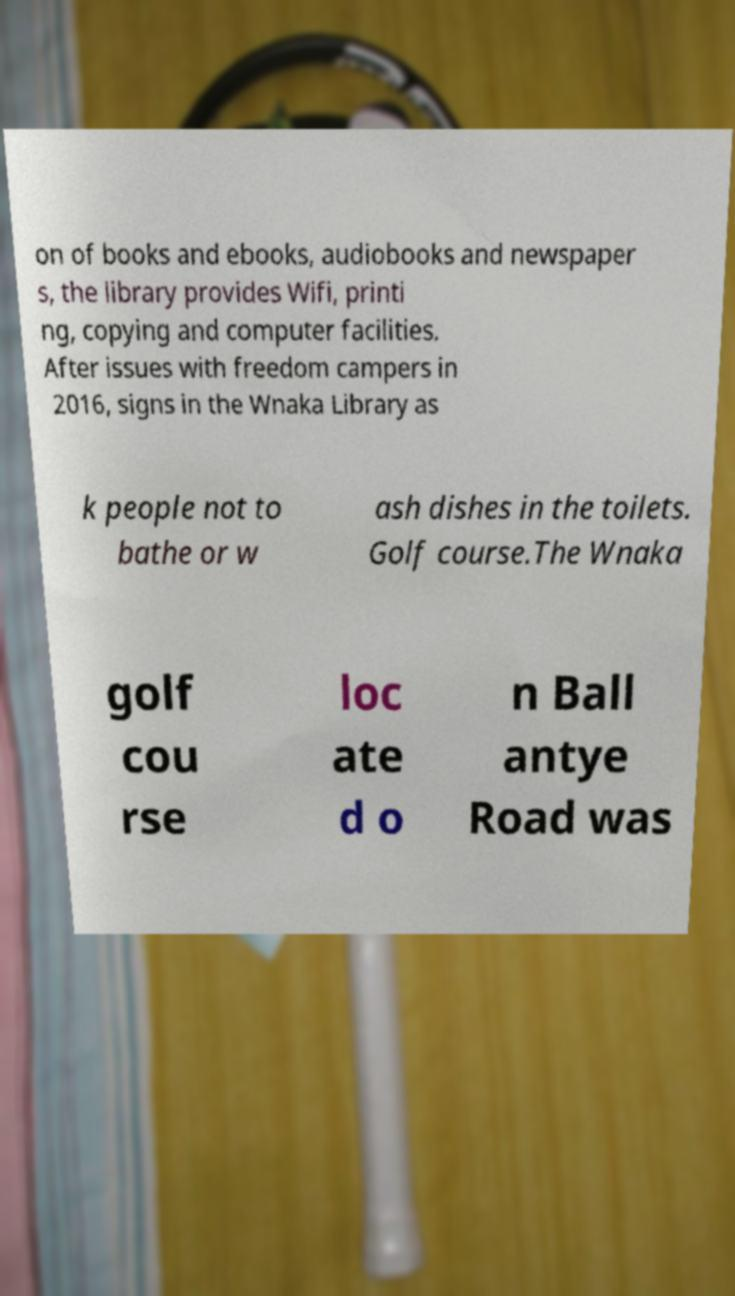Please identify and transcribe the text found in this image. on of books and ebooks, audiobooks and newspaper s, the library provides Wifi, printi ng, copying and computer facilities. After issues with freedom campers in 2016, signs in the Wnaka Library as k people not to bathe or w ash dishes in the toilets. Golf course.The Wnaka golf cou rse loc ate d o n Ball antye Road was 